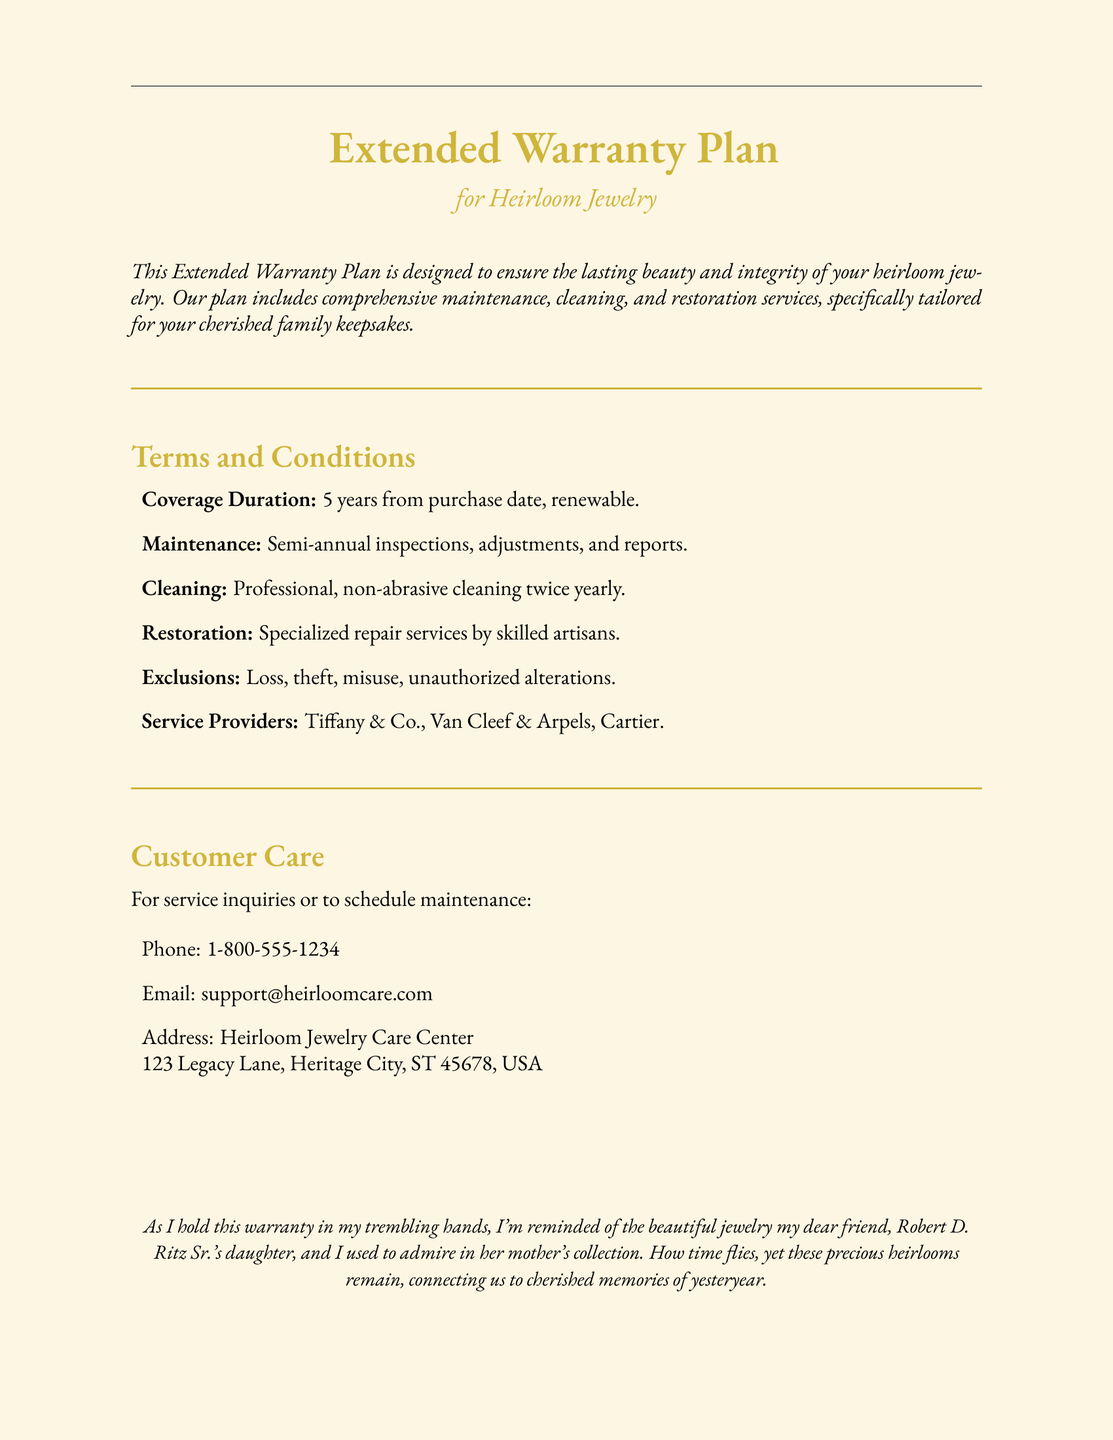what is the coverage duration of the warranty? The document states that the warranty coverage lasts for 5 years from the purchase date and is renewable.
Answer: 5 years how often will maintenance be performed? According to the document, maintenance inspections are scheduled to be semi-annual, which means they occur twice a year.
Answer: Semi-annual who are the service providers listed in the warranty? The document lists specific service providers for restoration services, which include Tiffany & Co., Van Cleef & Arpels, and Cartier.
Answer: Tiffany & Co., Van Cleef & Arpels, Cartier what type of cleaning is included in the plan? The document specifies that the cleaning provided is professional and non-abrasive, occurring twice yearly.
Answer: Professional, non-abrasive what is excluded from the warranty coverage? Loss, theft, misuse, and unauthorized alterations are among the exclusions mentioned in the warranty coverage.
Answer: Loss, theft, misuse, unauthorized alterations how can customers schedule maintenance? The document provides multiple contact options for scheduling maintenance, including phone and email details.
Answer: Phone: 1-800-555-1234, Email: support@heirloomcare.com what is the purpose of the Extended Warranty Plan? The document describes the plan as being designed to ensure the lasting beauty and integrity of heirloom jewelry.
Answer: Ensure lasting beauty and integrity what specific services are included in the restoration? The warranty mentions that specialized repair services will be provided by skilled artisans for restoration purposes.
Answer: Specialized repair services 